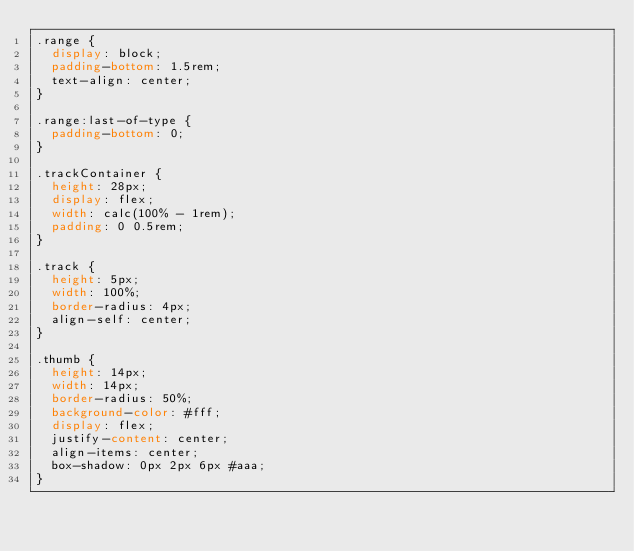<code> <loc_0><loc_0><loc_500><loc_500><_CSS_>.range {
  display: block;
  padding-bottom: 1.5rem;
  text-align: center;
}

.range:last-of-type {
  padding-bottom: 0;
}

.trackContainer {
  height: 28px;
  display: flex;
  width: calc(100% - 1rem);
  padding: 0 0.5rem;
}

.track {
  height: 5px;
  width: 100%;
  border-radius: 4px;
  align-self: center;
}

.thumb {
  height: 14px;
  width: 14px;
  border-radius: 50%;
  background-color: #fff;
  display: flex;
  justify-content: center;
  align-items: center;
  box-shadow: 0px 2px 6px #aaa;
}
</code> 